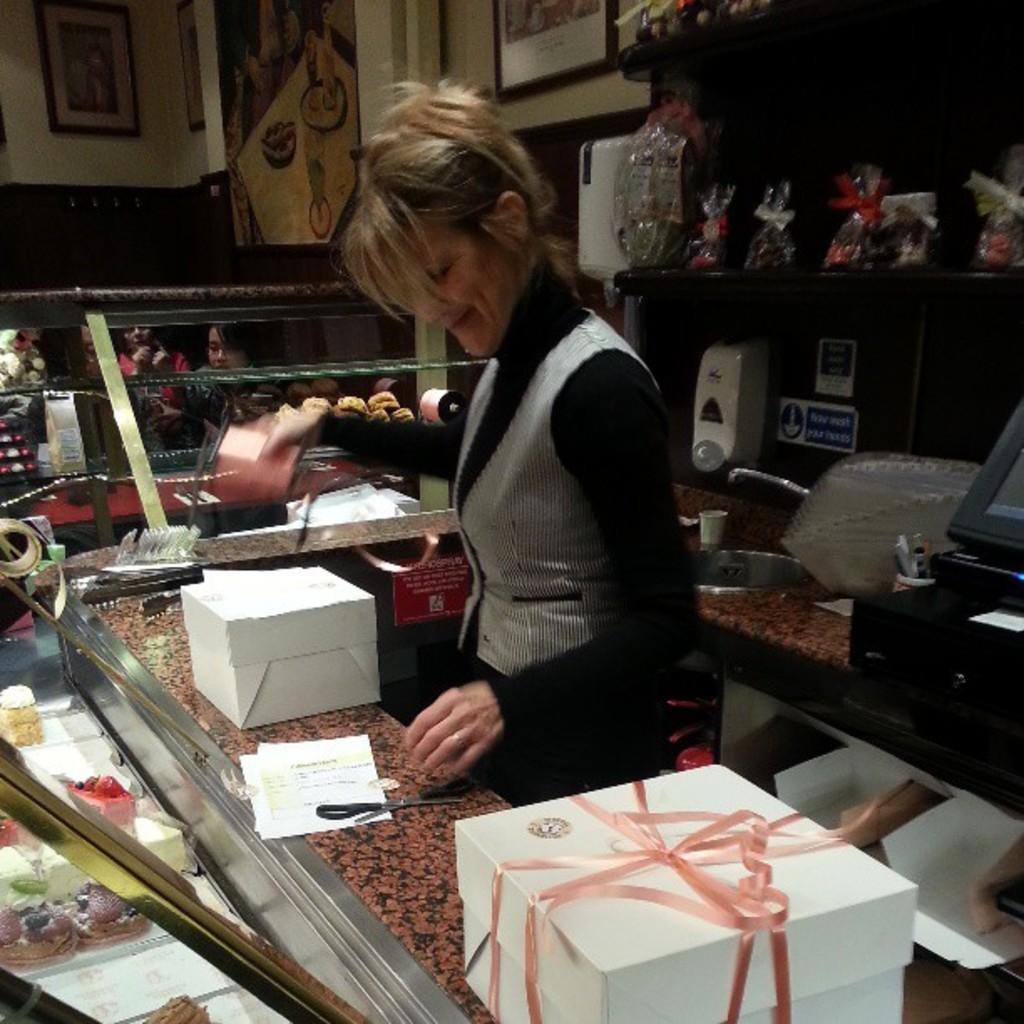Could you give a brief overview of what you see in this image? In this picture we can see a woman standing and smiling. There are few boxes, papers and scissor on the table. We can see a device, tap, sink, white object and few papers on the wall. We can see few cakes on the left side. There are some food packets on the shelf. Few frames are visible on the wall. Some people are visible in the background. 